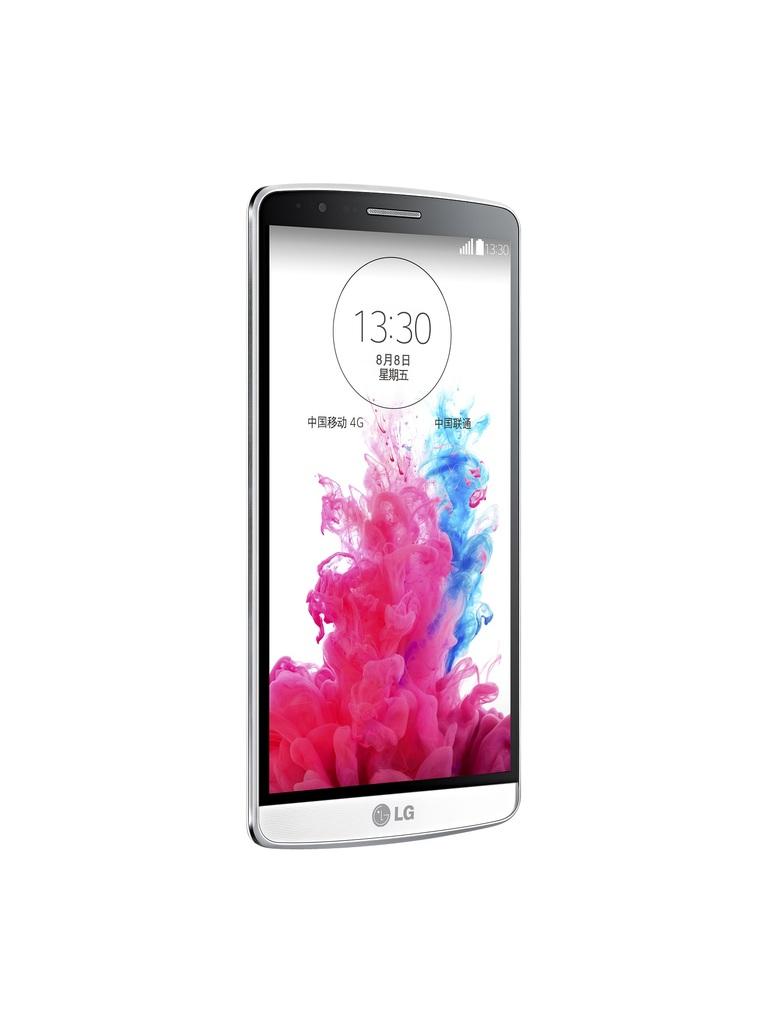What brand of smartphone is shown?
Make the answer very short. Lg. 